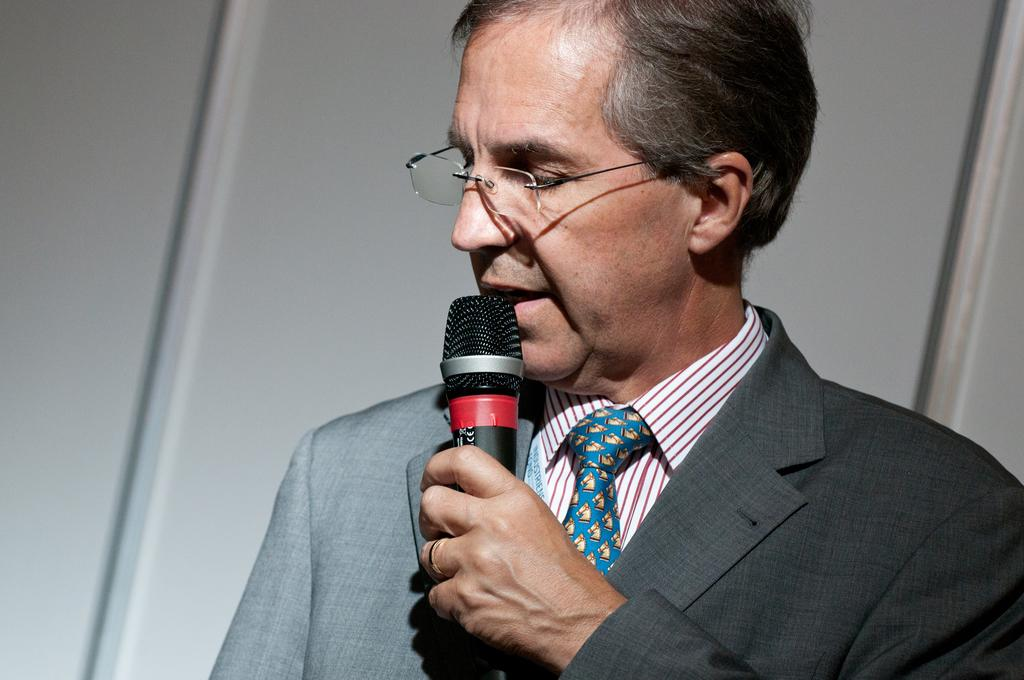What is the main subject of the image? The main subject of the image is a man. What is the man holding in the image? The man is holding a mic in the image. How many hooks can be seen hanging from the man's clothing in the image? There are no hooks visible on the man's clothing in the image. 